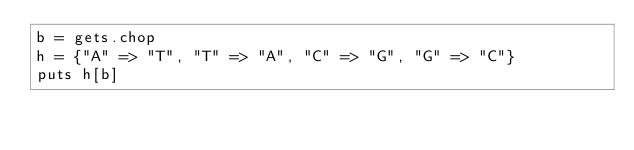<code> <loc_0><loc_0><loc_500><loc_500><_Ruby_>b = gets.chop
h = {"A" => "T", "T" => "A", "C" => "G", "G" => "C"}
puts h[b]</code> 